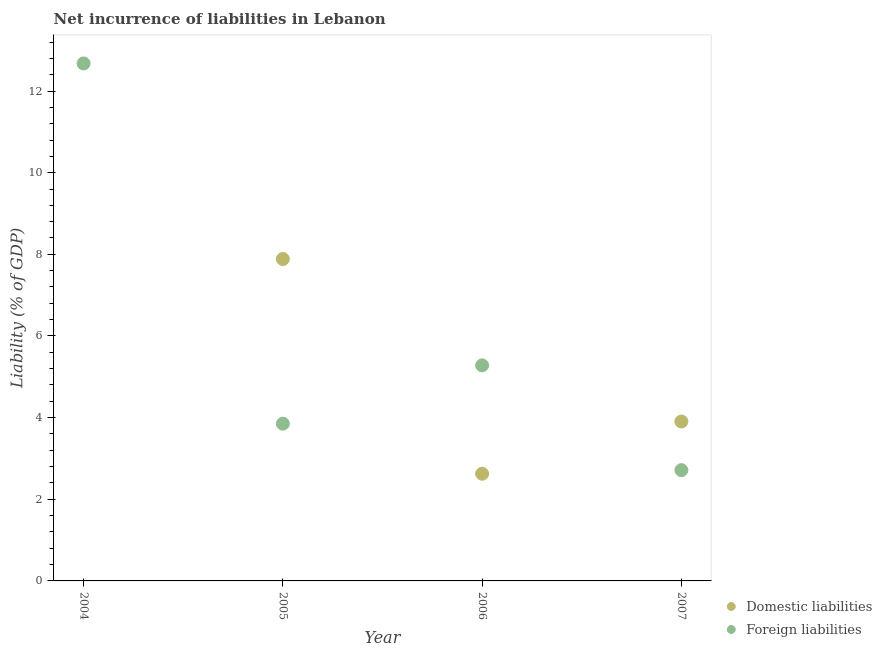How many different coloured dotlines are there?
Provide a short and direct response. 2. Is the number of dotlines equal to the number of legend labels?
Give a very brief answer. No. What is the incurrence of foreign liabilities in 2007?
Your response must be concise. 2.71. Across all years, what is the maximum incurrence of foreign liabilities?
Make the answer very short. 12.68. Across all years, what is the minimum incurrence of foreign liabilities?
Make the answer very short. 2.71. What is the total incurrence of foreign liabilities in the graph?
Ensure brevity in your answer.  24.52. What is the difference between the incurrence of foreign liabilities in 2004 and that in 2005?
Give a very brief answer. 8.82. What is the difference between the incurrence of domestic liabilities in 2006 and the incurrence of foreign liabilities in 2005?
Your answer should be compact. -1.23. What is the average incurrence of domestic liabilities per year?
Keep it short and to the point. 3.6. In the year 2005, what is the difference between the incurrence of domestic liabilities and incurrence of foreign liabilities?
Your answer should be compact. 4.03. What is the ratio of the incurrence of foreign liabilities in 2004 to that in 2005?
Keep it short and to the point. 3.29. Is the incurrence of foreign liabilities in 2005 less than that in 2007?
Your answer should be compact. No. What is the difference between the highest and the second highest incurrence of domestic liabilities?
Your answer should be compact. 3.98. What is the difference between the highest and the lowest incurrence of foreign liabilities?
Offer a terse response. 9.96. Is the sum of the incurrence of domestic liabilities in 2006 and 2007 greater than the maximum incurrence of foreign liabilities across all years?
Provide a succinct answer. No. How many dotlines are there?
Your response must be concise. 2. How many years are there in the graph?
Keep it short and to the point. 4. Does the graph contain grids?
Offer a terse response. No. Where does the legend appear in the graph?
Offer a very short reply. Bottom right. What is the title of the graph?
Provide a short and direct response. Net incurrence of liabilities in Lebanon. What is the label or title of the X-axis?
Ensure brevity in your answer.  Year. What is the label or title of the Y-axis?
Offer a very short reply. Liability (% of GDP). What is the Liability (% of GDP) in Foreign liabilities in 2004?
Keep it short and to the point. 12.68. What is the Liability (% of GDP) in Domestic liabilities in 2005?
Ensure brevity in your answer.  7.89. What is the Liability (% of GDP) in Foreign liabilities in 2005?
Offer a very short reply. 3.85. What is the Liability (% of GDP) of Domestic liabilities in 2006?
Your answer should be compact. 2.63. What is the Liability (% of GDP) of Foreign liabilities in 2006?
Your answer should be compact. 5.28. What is the Liability (% of GDP) in Domestic liabilities in 2007?
Make the answer very short. 3.9. What is the Liability (% of GDP) in Foreign liabilities in 2007?
Offer a terse response. 2.71. Across all years, what is the maximum Liability (% of GDP) of Domestic liabilities?
Keep it short and to the point. 7.89. Across all years, what is the maximum Liability (% of GDP) in Foreign liabilities?
Your answer should be very brief. 12.68. Across all years, what is the minimum Liability (% of GDP) of Foreign liabilities?
Offer a terse response. 2.71. What is the total Liability (% of GDP) of Domestic liabilities in the graph?
Your response must be concise. 14.42. What is the total Liability (% of GDP) of Foreign liabilities in the graph?
Offer a terse response. 24.52. What is the difference between the Liability (% of GDP) of Foreign liabilities in 2004 and that in 2005?
Your response must be concise. 8.82. What is the difference between the Liability (% of GDP) of Foreign liabilities in 2004 and that in 2006?
Your answer should be compact. 7.4. What is the difference between the Liability (% of GDP) of Foreign liabilities in 2004 and that in 2007?
Offer a terse response. 9.96. What is the difference between the Liability (% of GDP) of Domestic liabilities in 2005 and that in 2006?
Provide a short and direct response. 5.26. What is the difference between the Liability (% of GDP) in Foreign liabilities in 2005 and that in 2006?
Offer a very short reply. -1.43. What is the difference between the Liability (% of GDP) of Domestic liabilities in 2005 and that in 2007?
Your answer should be compact. 3.98. What is the difference between the Liability (% of GDP) in Foreign liabilities in 2005 and that in 2007?
Your answer should be compact. 1.14. What is the difference between the Liability (% of GDP) in Domestic liabilities in 2006 and that in 2007?
Keep it short and to the point. -1.28. What is the difference between the Liability (% of GDP) of Foreign liabilities in 2006 and that in 2007?
Your response must be concise. 2.57. What is the difference between the Liability (% of GDP) in Domestic liabilities in 2005 and the Liability (% of GDP) in Foreign liabilities in 2006?
Offer a very short reply. 2.61. What is the difference between the Liability (% of GDP) in Domestic liabilities in 2005 and the Liability (% of GDP) in Foreign liabilities in 2007?
Your answer should be compact. 5.17. What is the difference between the Liability (% of GDP) of Domestic liabilities in 2006 and the Liability (% of GDP) of Foreign liabilities in 2007?
Give a very brief answer. -0.09. What is the average Liability (% of GDP) in Domestic liabilities per year?
Keep it short and to the point. 3.6. What is the average Liability (% of GDP) in Foreign liabilities per year?
Offer a very short reply. 6.13. In the year 2005, what is the difference between the Liability (% of GDP) of Domestic liabilities and Liability (% of GDP) of Foreign liabilities?
Your answer should be compact. 4.03. In the year 2006, what is the difference between the Liability (% of GDP) in Domestic liabilities and Liability (% of GDP) in Foreign liabilities?
Your response must be concise. -2.65. In the year 2007, what is the difference between the Liability (% of GDP) in Domestic liabilities and Liability (% of GDP) in Foreign liabilities?
Your answer should be compact. 1.19. What is the ratio of the Liability (% of GDP) of Foreign liabilities in 2004 to that in 2005?
Give a very brief answer. 3.29. What is the ratio of the Liability (% of GDP) of Foreign liabilities in 2004 to that in 2006?
Offer a very short reply. 2.4. What is the ratio of the Liability (% of GDP) in Foreign liabilities in 2004 to that in 2007?
Provide a succinct answer. 4.67. What is the ratio of the Liability (% of GDP) in Domestic liabilities in 2005 to that in 2006?
Provide a succinct answer. 3. What is the ratio of the Liability (% of GDP) of Foreign liabilities in 2005 to that in 2006?
Your response must be concise. 0.73. What is the ratio of the Liability (% of GDP) of Domestic liabilities in 2005 to that in 2007?
Provide a succinct answer. 2.02. What is the ratio of the Liability (% of GDP) of Foreign liabilities in 2005 to that in 2007?
Ensure brevity in your answer.  1.42. What is the ratio of the Liability (% of GDP) of Domestic liabilities in 2006 to that in 2007?
Offer a terse response. 0.67. What is the ratio of the Liability (% of GDP) in Foreign liabilities in 2006 to that in 2007?
Offer a very short reply. 1.95. What is the difference between the highest and the second highest Liability (% of GDP) in Domestic liabilities?
Offer a very short reply. 3.98. What is the difference between the highest and the second highest Liability (% of GDP) in Foreign liabilities?
Your response must be concise. 7.4. What is the difference between the highest and the lowest Liability (% of GDP) in Domestic liabilities?
Keep it short and to the point. 7.89. What is the difference between the highest and the lowest Liability (% of GDP) of Foreign liabilities?
Give a very brief answer. 9.96. 